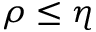<formula> <loc_0><loc_0><loc_500><loc_500>\rho \leq \eta</formula> 